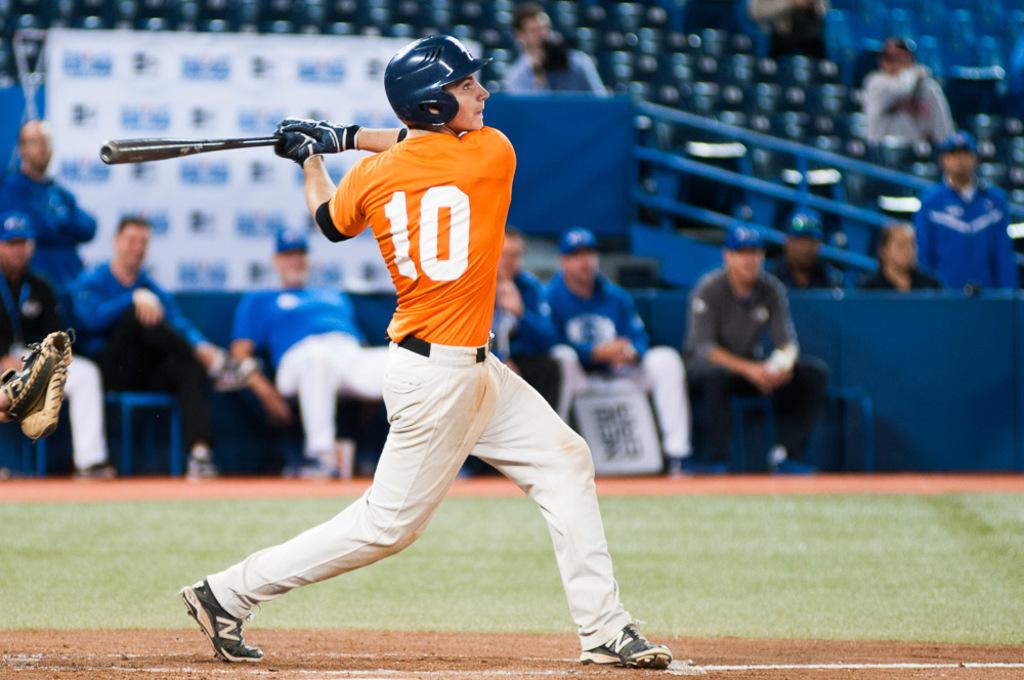What letter is on the batters shoe?
Make the answer very short. N. 